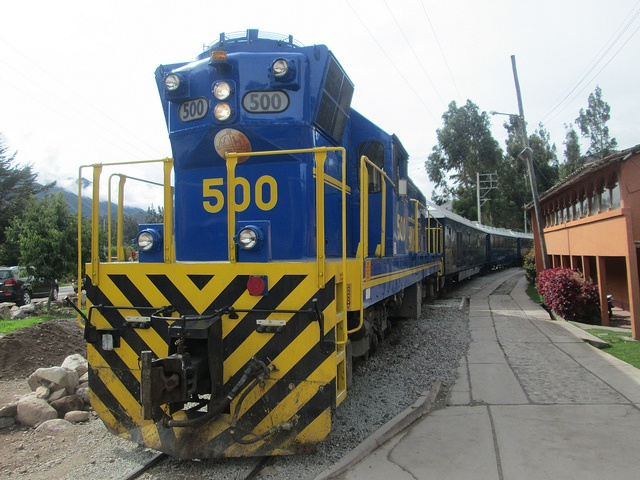Describe the objects in this image and their specific colors. I can see train in white, black, navy, olive, and gray tones, truck in white, black, gray, darkgray, and maroon tones, and car in white, black, gray, darkgray, and maroon tones in this image. 